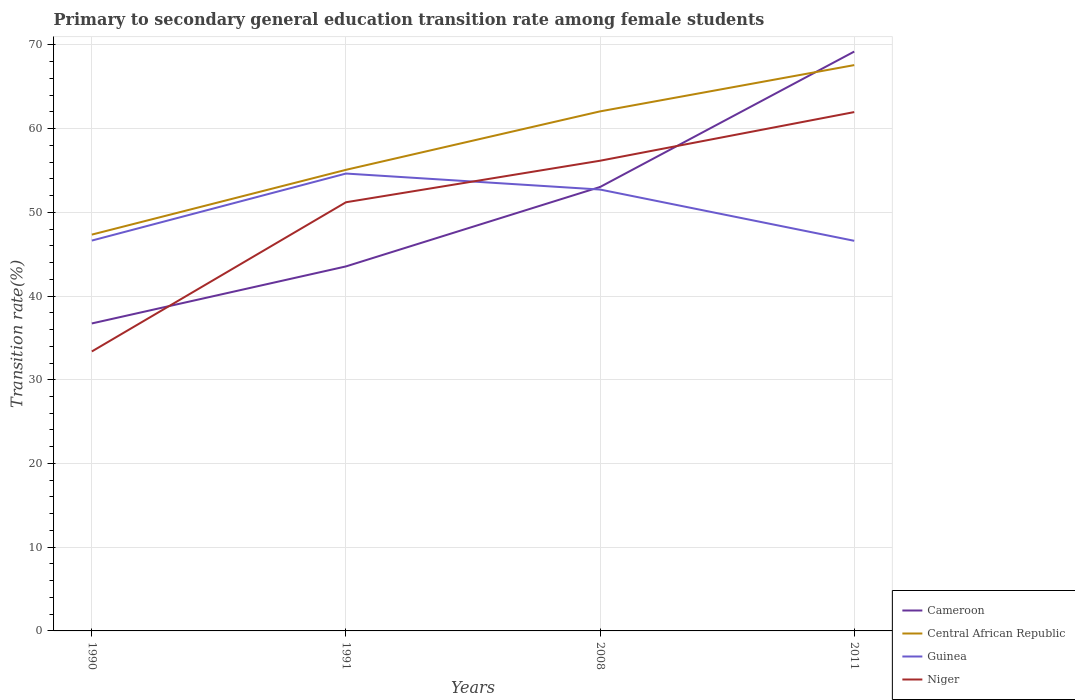Across all years, what is the maximum transition rate in Niger?
Offer a terse response. 33.38. In which year was the transition rate in Niger maximum?
Keep it short and to the point. 1990. What is the total transition rate in Central African Republic in the graph?
Offer a very short reply. -12.51. What is the difference between the highest and the second highest transition rate in Guinea?
Offer a terse response. 8.03. Is the transition rate in Central African Republic strictly greater than the transition rate in Guinea over the years?
Ensure brevity in your answer.  No. How many lines are there?
Make the answer very short. 4. How many years are there in the graph?
Your answer should be very brief. 4. Are the values on the major ticks of Y-axis written in scientific E-notation?
Your answer should be very brief. No. How many legend labels are there?
Make the answer very short. 4. What is the title of the graph?
Ensure brevity in your answer.  Primary to secondary general education transition rate among female students. Does "Liechtenstein" appear as one of the legend labels in the graph?
Make the answer very short. No. What is the label or title of the X-axis?
Offer a very short reply. Years. What is the label or title of the Y-axis?
Give a very brief answer. Transition rate(%). What is the Transition rate(%) of Cameroon in 1990?
Your response must be concise. 36.73. What is the Transition rate(%) of Central African Republic in 1990?
Give a very brief answer. 47.34. What is the Transition rate(%) in Guinea in 1990?
Your response must be concise. 46.62. What is the Transition rate(%) of Niger in 1990?
Offer a very short reply. 33.38. What is the Transition rate(%) of Cameroon in 1991?
Give a very brief answer. 43.54. What is the Transition rate(%) in Central African Republic in 1991?
Offer a very short reply. 55.07. What is the Transition rate(%) in Guinea in 1991?
Your answer should be very brief. 54.63. What is the Transition rate(%) in Niger in 1991?
Provide a short and direct response. 51.2. What is the Transition rate(%) in Cameroon in 2008?
Offer a very short reply. 53.03. What is the Transition rate(%) of Central African Republic in 2008?
Your answer should be compact. 62.06. What is the Transition rate(%) in Guinea in 2008?
Give a very brief answer. 52.72. What is the Transition rate(%) in Niger in 2008?
Keep it short and to the point. 56.16. What is the Transition rate(%) in Cameroon in 2011?
Offer a very short reply. 69.2. What is the Transition rate(%) in Central African Republic in 2011?
Make the answer very short. 67.58. What is the Transition rate(%) of Guinea in 2011?
Your answer should be very brief. 46.59. What is the Transition rate(%) in Niger in 2011?
Keep it short and to the point. 61.97. Across all years, what is the maximum Transition rate(%) of Cameroon?
Provide a short and direct response. 69.2. Across all years, what is the maximum Transition rate(%) of Central African Republic?
Your answer should be very brief. 67.58. Across all years, what is the maximum Transition rate(%) of Guinea?
Ensure brevity in your answer.  54.63. Across all years, what is the maximum Transition rate(%) in Niger?
Keep it short and to the point. 61.97. Across all years, what is the minimum Transition rate(%) in Cameroon?
Give a very brief answer. 36.73. Across all years, what is the minimum Transition rate(%) of Central African Republic?
Provide a short and direct response. 47.34. Across all years, what is the minimum Transition rate(%) of Guinea?
Make the answer very short. 46.59. Across all years, what is the minimum Transition rate(%) in Niger?
Ensure brevity in your answer.  33.38. What is the total Transition rate(%) in Cameroon in the graph?
Provide a short and direct response. 202.49. What is the total Transition rate(%) in Central African Republic in the graph?
Give a very brief answer. 232.05. What is the total Transition rate(%) of Guinea in the graph?
Your answer should be very brief. 200.57. What is the total Transition rate(%) in Niger in the graph?
Your answer should be compact. 202.71. What is the difference between the Transition rate(%) in Cameroon in 1990 and that in 1991?
Keep it short and to the point. -6.81. What is the difference between the Transition rate(%) of Central African Republic in 1990 and that in 1991?
Provide a succinct answer. -7.74. What is the difference between the Transition rate(%) in Guinea in 1990 and that in 1991?
Ensure brevity in your answer.  -8. What is the difference between the Transition rate(%) of Niger in 1990 and that in 1991?
Ensure brevity in your answer.  -17.82. What is the difference between the Transition rate(%) of Cameroon in 1990 and that in 2008?
Ensure brevity in your answer.  -16.3. What is the difference between the Transition rate(%) of Central African Republic in 1990 and that in 2008?
Your answer should be very brief. -14.72. What is the difference between the Transition rate(%) of Guinea in 1990 and that in 2008?
Offer a terse response. -6.09. What is the difference between the Transition rate(%) of Niger in 1990 and that in 2008?
Your answer should be compact. -22.78. What is the difference between the Transition rate(%) in Cameroon in 1990 and that in 2011?
Ensure brevity in your answer.  -32.47. What is the difference between the Transition rate(%) of Central African Republic in 1990 and that in 2011?
Make the answer very short. -20.25. What is the difference between the Transition rate(%) of Guinea in 1990 and that in 2011?
Offer a very short reply. 0.03. What is the difference between the Transition rate(%) of Niger in 1990 and that in 2011?
Your answer should be compact. -28.59. What is the difference between the Transition rate(%) in Cameroon in 1991 and that in 2008?
Provide a short and direct response. -9.49. What is the difference between the Transition rate(%) in Central African Republic in 1991 and that in 2008?
Your response must be concise. -6.98. What is the difference between the Transition rate(%) of Guinea in 1991 and that in 2008?
Your response must be concise. 1.91. What is the difference between the Transition rate(%) in Niger in 1991 and that in 2008?
Offer a very short reply. -4.96. What is the difference between the Transition rate(%) in Cameroon in 1991 and that in 2011?
Your response must be concise. -25.66. What is the difference between the Transition rate(%) in Central African Republic in 1991 and that in 2011?
Keep it short and to the point. -12.51. What is the difference between the Transition rate(%) in Guinea in 1991 and that in 2011?
Make the answer very short. 8.03. What is the difference between the Transition rate(%) of Niger in 1991 and that in 2011?
Give a very brief answer. -10.77. What is the difference between the Transition rate(%) of Cameroon in 2008 and that in 2011?
Your response must be concise. -16.17. What is the difference between the Transition rate(%) of Central African Republic in 2008 and that in 2011?
Your answer should be compact. -5.53. What is the difference between the Transition rate(%) in Guinea in 2008 and that in 2011?
Your answer should be very brief. 6.12. What is the difference between the Transition rate(%) of Niger in 2008 and that in 2011?
Provide a short and direct response. -5.81. What is the difference between the Transition rate(%) of Cameroon in 1990 and the Transition rate(%) of Central African Republic in 1991?
Provide a short and direct response. -18.35. What is the difference between the Transition rate(%) in Cameroon in 1990 and the Transition rate(%) in Guinea in 1991?
Make the answer very short. -17.9. What is the difference between the Transition rate(%) in Cameroon in 1990 and the Transition rate(%) in Niger in 1991?
Provide a succinct answer. -14.48. What is the difference between the Transition rate(%) in Central African Republic in 1990 and the Transition rate(%) in Guinea in 1991?
Your answer should be very brief. -7.29. What is the difference between the Transition rate(%) of Central African Republic in 1990 and the Transition rate(%) of Niger in 1991?
Your answer should be compact. -3.87. What is the difference between the Transition rate(%) in Guinea in 1990 and the Transition rate(%) in Niger in 1991?
Ensure brevity in your answer.  -4.58. What is the difference between the Transition rate(%) in Cameroon in 1990 and the Transition rate(%) in Central African Republic in 2008?
Keep it short and to the point. -25.33. What is the difference between the Transition rate(%) in Cameroon in 1990 and the Transition rate(%) in Guinea in 2008?
Make the answer very short. -15.99. What is the difference between the Transition rate(%) of Cameroon in 1990 and the Transition rate(%) of Niger in 2008?
Offer a terse response. -19.44. What is the difference between the Transition rate(%) of Central African Republic in 1990 and the Transition rate(%) of Guinea in 2008?
Provide a short and direct response. -5.38. What is the difference between the Transition rate(%) in Central African Republic in 1990 and the Transition rate(%) in Niger in 2008?
Provide a short and direct response. -8.83. What is the difference between the Transition rate(%) in Guinea in 1990 and the Transition rate(%) in Niger in 2008?
Provide a short and direct response. -9.54. What is the difference between the Transition rate(%) of Cameroon in 1990 and the Transition rate(%) of Central African Republic in 2011?
Provide a short and direct response. -30.86. What is the difference between the Transition rate(%) of Cameroon in 1990 and the Transition rate(%) of Guinea in 2011?
Offer a very short reply. -9.87. What is the difference between the Transition rate(%) in Cameroon in 1990 and the Transition rate(%) in Niger in 2011?
Keep it short and to the point. -25.25. What is the difference between the Transition rate(%) of Central African Republic in 1990 and the Transition rate(%) of Guinea in 2011?
Provide a short and direct response. 0.74. What is the difference between the Transition rate(%) in Central African Republic in 1990 and the Transition rate(%) in Niger in 2011?
Make the answer very short. -14.64. What is the difference between the Transition rate(%) in Guinea in 1990 and the Transition rate(%) in Niger in 2011?
Keep it short and to the point. -15.35. What is the difference between the Transition rate(%) of Cameroon in 1991 and the Transition rate(%) of Central African Republic in 2008?
Ensure brevity in your answer.  -18.52. What is the difference between the Transition rate(%) of Cameroon in 1991 and the Transition rate(%) of Guinea in 2008?
Make the answer very short. -9.18. What is the difference between the Transition rate(%) in Cameroon in 1991 and the Transition rate(%) in Niger in 2008?
Provide a succinct answer. -12.62. What is the difference between the Transition rate(%) of Central African Republic in 1991 and the Transition rate(%) of Guinea in 2008?
Ensure brevity in your answer.  2.35. What is the difference between the Transition rate(%) of Central African Republic in 1991 and the Transition rate(%) of Niger in 2008?
Provide a short and direct response. -1.09. What is the difference between the Transition rate(%) in Guinea in 1991 and the Transition rate(%) in Niger in 2008?
Give a very brief answer. -1.53. What is the difference between the Transition rate(%) in Cameroon in 1991 and the Transition rate(%) in Central African Republic in 2011?
Your answer should be compact. -24.04. What is the difference between the Transition rate(%) in Cameroon in 1991 and the Transition rate(%) in Guinea in 2011?
Your answer should be compact. -3.06. What is the difference between the Transition rate(%) of Cameroon in 1991 and the Transition rate(%) of Niger in 2011?
Your response must be concise. -18.43. What is the difference between the Transition rate(%) of Central African Republic in 1991 and the Transition rate(%) of Guinea in 2011?
Give a very brief answer. 8.48. What is the difference between the Transition rate(%) in Central African Republic in 1991 and the Transition rate(%) in Niger in 2011?
Provide a succinct answer. -6.9. What is the difference between the Transition rate(%) of Guinea in 1991 and the Transition rate(%) of Niger in 2011?
Your response must be concise. -7.34. What is the difference between the Transition rate(%) in Cameroon in 2008 and the Transition rate(%) in Central African Republic in 2011?
Offer a terse response. -14.56. What is the difference between the Transition rate(%) of Cameroon in 2008 and the Transition rate(%) of Guinea in 2011?
Your answer should be compact. 6.43. What is the difference between the Transition rate(%) of Cameroon in 2008 and the Transition rate(%) of Niger in 2011?
Offer a terse response. -8.95. What is the difference between the Transition rate(%) in Central African Republic in 2008 and the Transition rate(%) in Guinea in 2011?
Make the answer very short. 15.46. What is the difference between the Transition rate(%) in Central African Republic in 2008 and the Transition rate(%) in Niger in 2011?
Ensure brevity in your answer.  0.08. What is the difference between the Transition rate(%) of Guinea in 2008 and the Transition rate(%) of Niger in 2011?
Your response must be concise. -9.25. What is the average Transition rate(%) of Cameroon per year?
Offer a very short reply. 50.62. What is the average Transition rate(%) in Central African Republic per year?
Provide a succinct answer. 58.01. What is the average Transition rate(%) of Guinea per year?
Make the answer very short. 50.14. What is the average Transition rate(%) in Niger per year?
Your answer should be compact. 50.68. In the year 1990, what is the difference between the Transition rate(%) of Cameroon and Transition rate(%) of Central African Republic?
Offer a very short reply. -10.61. In the year 1990, what is the difference between the Transition rate(%) in Cameroon and Transition rate(%) in Guinea?
Your answer should be very brief. -9.9. In the year 1990, what is the difference between the Transition rate(%) in Cameroon and Transition rate(%) in Niger?
Keep it short and to the point. 3.35. In the year 1990, what is the difference between the Transition rate(%) of Central African Republic and Transition rate(%) of Guinea?
Offer a terse response. 0.71. In the year 1990, what is the difference between the Transition rate(%) in Central African Republic and Transition rate(%) in Niger?
Offer a very short reply. 13.95. In the year 1990, what is the difference between the Transition rate(%) in Guinea and Transition rate(%) in Niger?
Your answer should be compact. 13.24. In the year 1991, what is the difference between the Transition rate(%) of Cameroon and Transition rate(%) of Central African Republic?
Your answer should be compact. -11.54. In the year 1991, what is the difference between the Transition rate(%) of Cameroon and Transition rate(%) of Guinea?
Your response must be concise. -11.09. In the year 1991, what is the difference between the Transition rate(%) of Cameroon and Transition rate(%) of Niger?
Your answer should be very brief. -7.66. In the year 1991, what is the difference between the Transition rate(%) of Central African Republic and Transition rate(%) of Guinea?
Make the answer very short. 0.45. In the year 1991, what is the difference between the Transition rate(%) in Central African Republic and Transition rate(%) in Niger?
Make the answer very short. 3.87. In the year 1991, what is the difference between the Transition rate(%) in Guinea and Transition rate(%) in Niger?
Ensure brevity in your answer.  3.43. In the year 2008, what is the difference between the Transition rate(%) in Cameroon and Transition rate(%) in Central African Republic?
Offer a terse response. -9.03. In the year 2008, what is the difference between the Transition rate(%) in Cameroon and Transition rate(%) in Guinea?
Give a very brief answer. 0.31. In the year 2008, what is the difference between the Transition rate(%) in Cameroon and Transition rate(%) in Niger?
Ensure brevity in your answer.  -3.14. In the year 2008, what is the difference between the Transition rate(%) of Central African Republic and Transition rate(%) of Guinea?
Give a very brief answer. 9.34. In the year 2008, what is the difference between the Transition rate(%) in Central African Republic and Transition rate(%) in Niger?
Your answer should be very brief. 5.89. In the year 2008, what is the difference between the Transition rate(%) in Guinea and Transition rate(%) in Niger?
Your answer should be very brief. -3.44. In the year 2011, what is the difference between the Transition rate(%) of Cameroon and Transition rate(%) of Central African Republic?
Offer a terse response. 1.62. In the year 2011, what is the difference between the Transition rate(%) of Cameroon and Transition rate(%) of Guinea?
Make the answer very short. 22.6. In the year 2011, what is the difference between the Transition rate(%) of Cameroon and Transition rate(%) of Niger?
Make the answer very short. 7.23. In the year 2011, what is the difference between the Transition rate(%) in Central African Republic and Transition rate(%) in Guinea?
Your answer should be very brief. 20.99. In the year 2011, what is the difference between the Transition rate(%) in Central African Republic and Transition rate(%) in Niger?
Your answer should be compact. 5.61. In the year 2011, what is the difference between the Transition rate(%) in Guinea and Transition rate(%) in Niger?
Make the answer very short. -15.38. What is the ratio of the Transition rate(%) of Cameroon in 1990 to that in 1991?
Your answer should be very brief. 0.84. What is the ratio of the Transition rate(%) of Central African Republic in 1990 to that in 1991?
Provide a succinct answer. 0.86. What is the ratio of the Transition rate(%) of Guinea in 1990 to that in 1991?
Provide a short and direct response. 0.85. What is the ratio of the Transition rate(%) in Niger in 1990 to that in 1991?
Provide a succinct answer. 0.65. What is the ratio of the Transition rate(%) of Cameroon in 1990 to that in 2008?
Your response must be concise. 0.69. What is the ratio of the Transition rate(%) of Central African Republic in 1990 to that in 2008?
Provide a short and direct response. 0.76. What is the ratio of the Transition rate(%) in Guinea in 1990 to that in 2008?
Make the answer very short. 0.88. What is the ratio of the Transition rate(%) in Niger in 1990 to that in 2008?
Your answer should be very brief. 0.59. What is the ratio of the Transition rate(%) in Cameroon in 1990 to that in 2011?
Your answer should be very brief. 0.53. What is the ratio of the Transition rate(%) in Central African Republic in 1990 to that in 2011?
Provide a short and direct response. 0.7. What is the ratio of the Transition rate(%) of Niger in 1990 to that in 2011?
Keep it short and to the point. 0.54. What is the ratio of the Transition rate(%) of Cameroon in 1991 to that in 2008?
Ensure brevity in your answer.  0.82. What is the ratio of the Transition rate(%) of Central African Republic in 1991 to that in 2008?
Ensure brevity in your answer.  0.89. What is the ratio of the Transition rate(%) of Guinea in 1991 to that in 2008?
Make the answer very short. 1.04. What is the ratio of the Transition rate(%) in Niger in 1991 to that in 2008?
Provide a succinct answer. 0.91. What is the ratio of the Transition rate(%) in Cameroon in 1991 to that in 2011?
Make the answer very short. 0.63. What is the ratio of the Transition rate(%) of Central African Republic in 1991 to that in 2011?
Offer a very short reply. 0.81. What is the ratio of the Transition rate(%) in Guinea in 1991 to that in 2011?
Ensure brevity in your answer.  1.17. What is the ratio of the Transition rate(%) in Niger in 1991 to that in 2011?
Your response must be concise. 0.83. What is the ratio of the Transition rate(%) in Cameroon in 2008 to that in 2011?
Offer a terse response. 0.77. What is the ratio of the Transition rate(%) of Central African Republic in 2008 to that in 2011?
Provide a succinct answer. 0.92. What is the ratio of the Transition rate(%) in Guinea in 2008 to that in 2011?
Your answer should be compact. 1.13. What is the ratio of the Transition rate(%) in Niger in 2008 to that in 2011?
Provide a succinct answer. 0.91. What is the difference between the highest and the second highest Transition rate(%) of Cameroon?
Offer a terse response. 16.17. What is the difference between the highest and the second highest Transition rate(%) of Central African Republic?
Provide a succinct answer. 5.53. What is the difference between the highest and the second highest Transition rate(%) of Guinea?
Your response must be concise. 1.91. What is the difference between the highest and the second highest Transition rate(%) of Niger?
Your answer should be very brief. 5.81. What is the difference between the highest and the lowest Transition rate(%) in Cameroon?
Offer a terse response. 32.47. What is the difference between the highest and the lowest Transition rate(%) in Central African Republic?
Your answer should be very brief. 20.25. What is the difference between the highest and the lowest Transition rate(%) of Guinea?
Keep it short and to the point. 8.03. What is the difference between the highest and the lowest Transition rate(%) of Niger?
Your answer should be very brief. 28.59. 